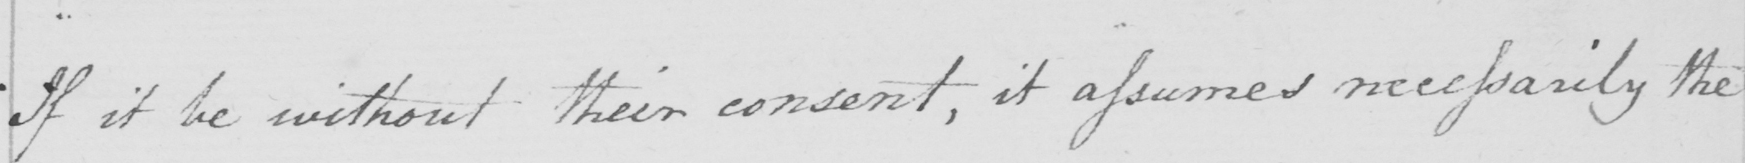Can you tell me what this handwritten text says? If it be without their consent , it assumes necessarily the 